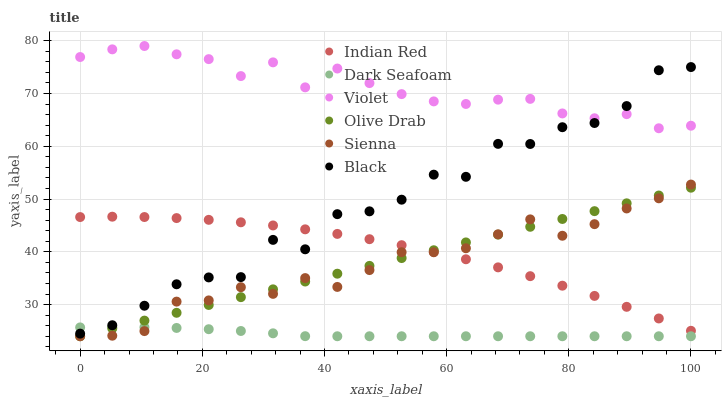Does Dark Seafoam have the minimum area under the curve?
Answer yes or no. Yes. Does Violet have the maximum area under the curve?
Answer yes or no. Yes. Does Black have the minimum area under the curve?
Answer yes or no. No. Does Black have the maximum area under the curve?
Answer yes or no. No. Is Olive Drab the smoothest?
Answer yes or no. Yes. Is Black the roughest?
Answer yes or no. Yes. Is Dark Seafoam the smoothest?
Answer yes or no. No. Is Dark Seafoam the roughest?
Answer yes or no. No. Does Sienna have the lowest value?
Answer yes or no. Yes. Does Black have the lowest value?
Answer yes or no. No. Does Violet have the highest value?
Answer yes or no. Yes. Does Black have the highest value?
Answer yes or no. No. Is Sienna less than Violet?
Answer yes or no. Yes. Is Violet greater than Olive Drab?
Answer yes or no. Yes. Does Indian Red intersect Sienna?
Answer yes or no. Yes. Is Indian Red less than Sienna?
Answer yes or no. No. Is Indian Red greater than Sienna?
Answer yes or no. No. Does Sienna intersect Violet?
Answer yes or no. No. 